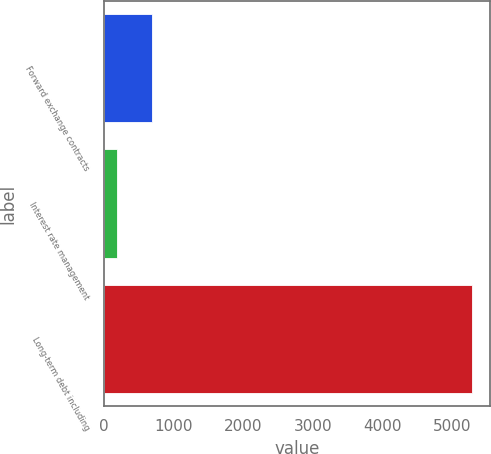Convert chart. <chart><loc_0><loc_0><loc_500><loc_500><bar_chart><fcel>Forward exchange contracts<fcel>Interest rate management<fcel>Long-term debt including<nl><fcel>690.85<fcel>179.9<fcel>5289.4<nl></chart> 